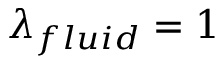<formula> <loc_0><loc_0><loc_500><loc_500>\lambda _ { f l u i d } = 1</formula> 